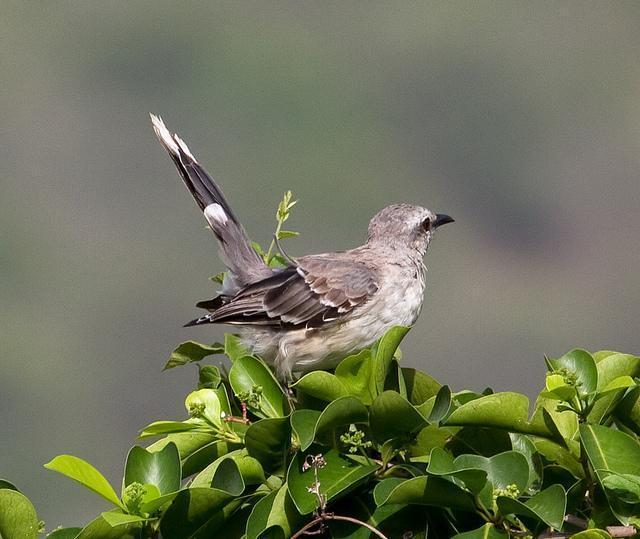How many birds?
Give a very brief answer. 1. How many people are riding bikes?
Give a very brief answer. 0. 